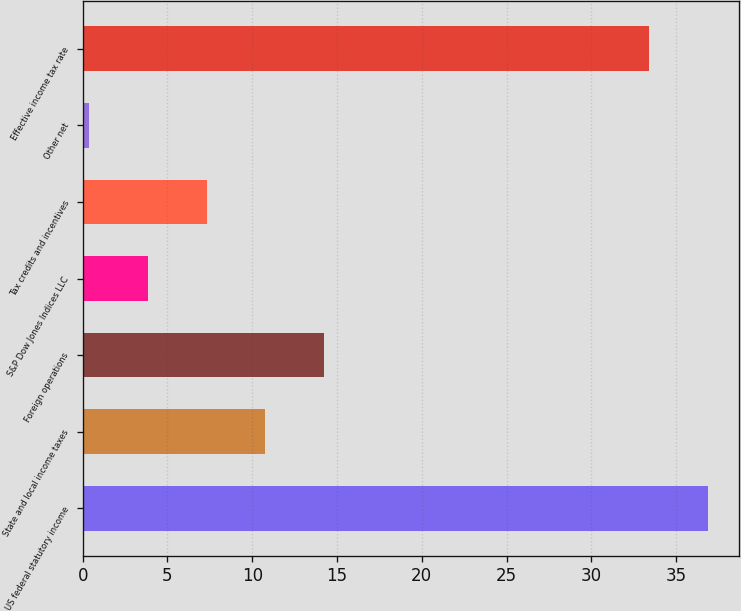Convert chart to OTSL. <chart><loc_0><loc_0><loc_500><loc_500><bar_chart><fcel>US federal statutory income<fcel>State and local income taxes<fcel>Foreign operations<fcel>S&P Dow Jones Indices LLC<fcel>Tax credits and incentives<fcel>Other net<fcel>Effective income tax rate<nl><fcel>36.86<fcel>10.78<fcel>14.24<fcel>3.86<fcel>7.32<fcel>0.4<fcel>33.4<nl></chart> 